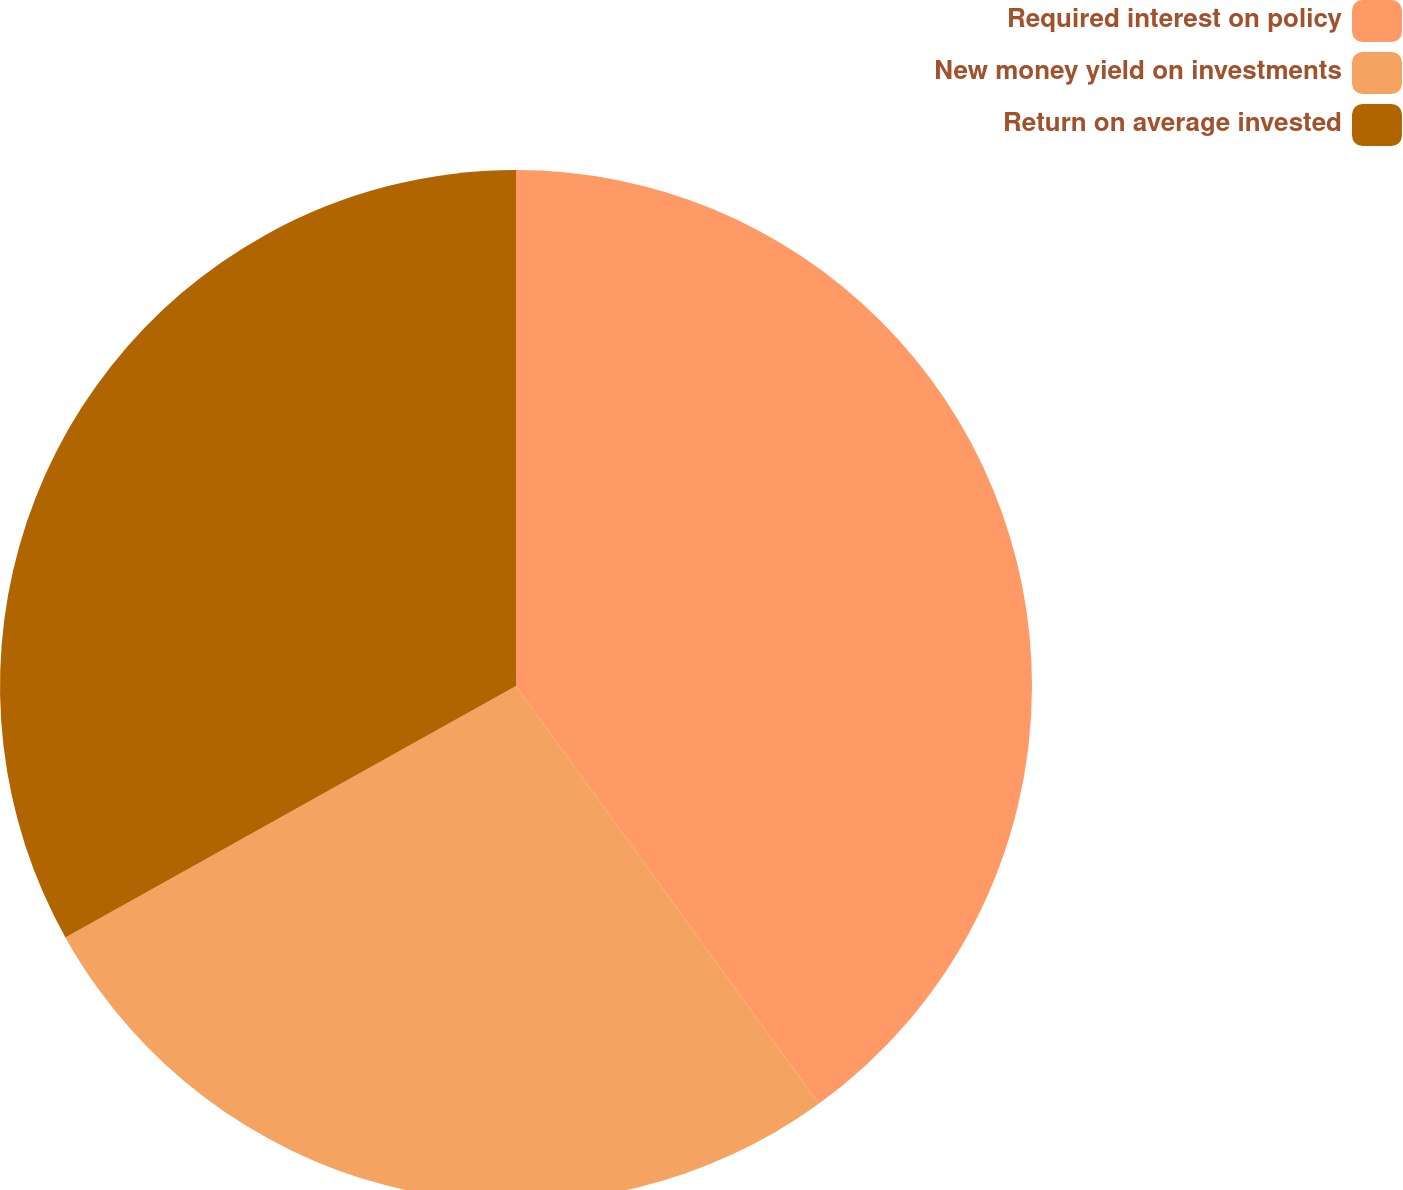<chart> <loc_0><loc_0><loc_500><loc_500><pie_chart><fcel>Required interest on policy<fcel>New money yield on investments<fcel>Return on average invested<nl><fcel>40.02%<fcel>26.88%<fcel>33.1%<nl></chart> 